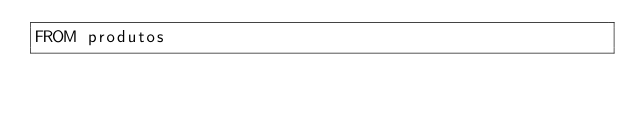Convert code to text. <code><loc_0><loc_0><loc_500><loc_500><_SQL_>FROM produtos</code> 